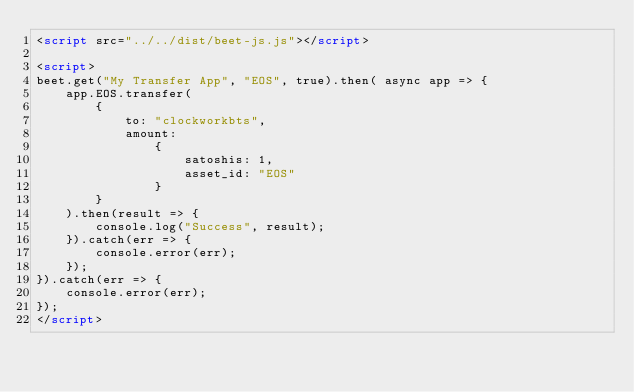Convert code to text. <code><loc_0><loc_0><loc_500><loc_500><_HTML_><script src="../../dist/beet-js.js"></script>

<script>
beet.get("My Transfer App", "EOS", true).then( async app => {
    app.EOS.transfer(
        {
            to: "clockworkbts",
            amount:
                {
                    satoshis: 1,
                    asset_id: "EOS"
                }
        }
    ).then(result => {
        console.log("Success", result);
    }).catch(err => {
        console.error(err);
    });
}).catch(err => {
    console.error(err);
});
</script></code> 